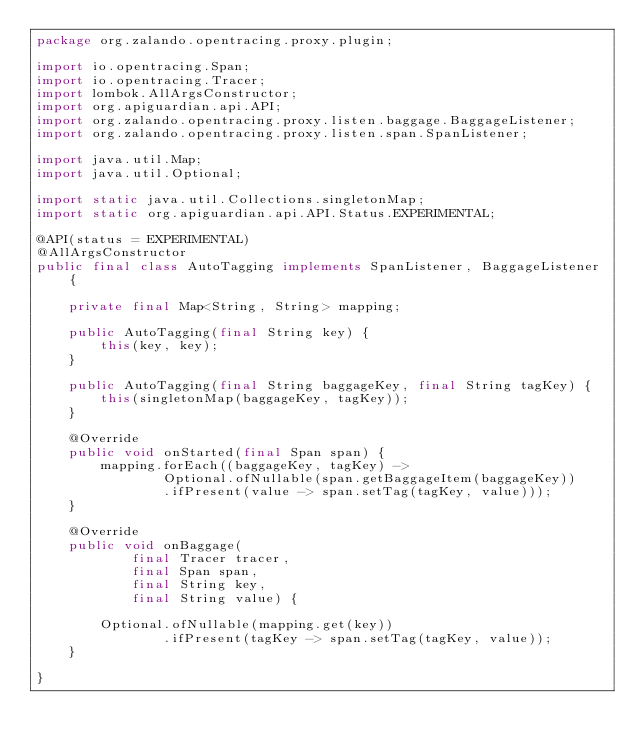<code> <loc_0><loc_0><loc_500><loc_500><_Java_>package org.zalando.opentracing.proxy.plugin;

import io.opentracing.Span;
import io.opentracing.Tracer;
import lombok.AllArgsConstructor;
import org.apiguardian.api.API;
import org.zalando.opentracing.proxy.listen.baggage.BaggageListener;
import org.zalando.opentracing.proxy.listen.span.SpanListener;

import java.util.Map;
import java.util.Optional;

import static java.util.Collections.singletonMap;
import static org.apiguardian.api.API.Status.EXPERIMENTAL;

@API(status = EXPERIMENTAL)
@AllArgsConstructor
public final class AutoTagging implements SpanListener, BaggageListener {

    private final Map<String, String> mapping;

    public AutoTagging(final String key) {
        this(key, key);
    }

    public AutoTagging(final String baggageKey, final String tagKey) {
        this(singletonMap(baggageKey, tagKey));
    }

    @Override
    public void onStarted(final Span span) {
        mapping.forEach((baggageKey, tagKey) ->
                Optional.ofNullable(span.getBaggageItem(baggageKey))
                .ifPresent(value -> span.setTag(tagKey, value)));
    }

    @Override
    public void onBaggage(
            final Tracer tracer,
            final Span span,
            final String key,
            final String value) {

        Optional.ofNullable(mapping.get(key))
                .ifPresent(tagKey -> span.setTag(tagKey, value));
    }

}
</code> 